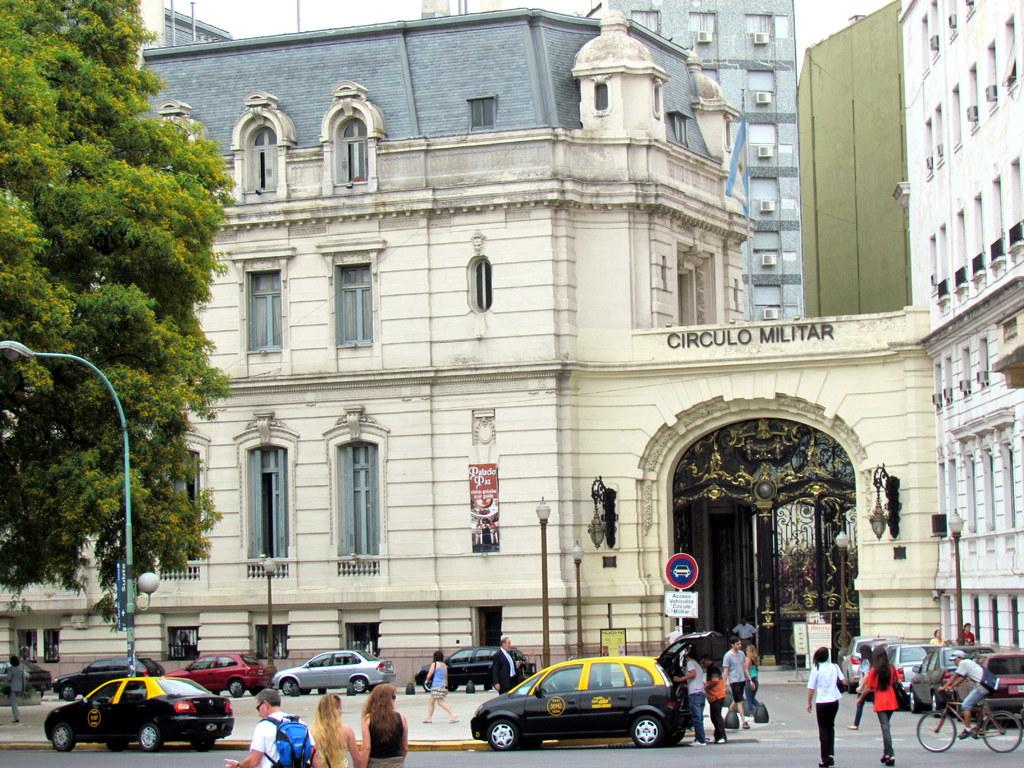<image>
Render a clear and concise summary of the photo. The front of a building that has the words circulo militar on its entrance. 